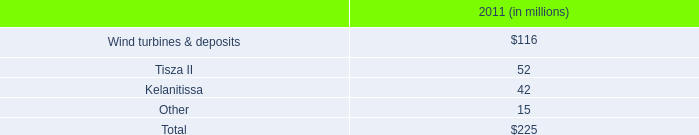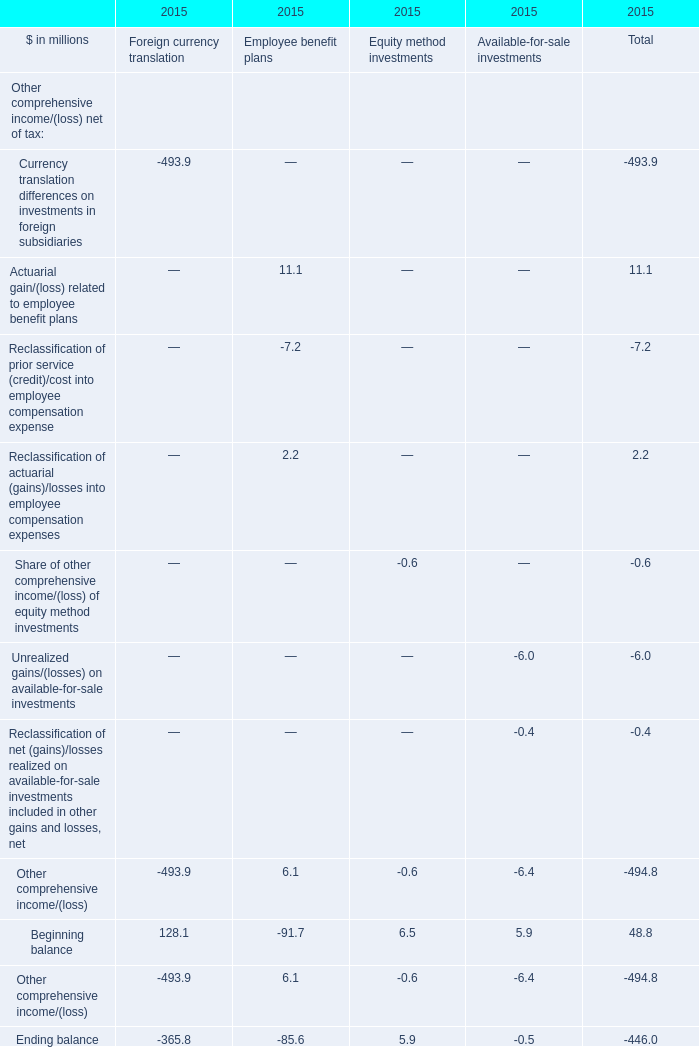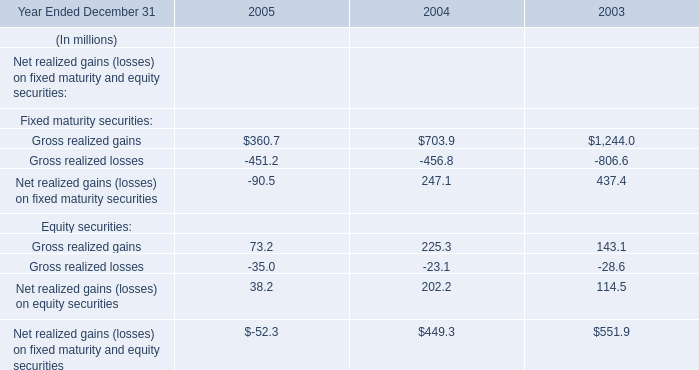What's the sum of all Employee benefit plans that are positive in 2015? (in million) 
Computations: ((11.1 + 2.2) + 6.1)
Answer: 19.4. 